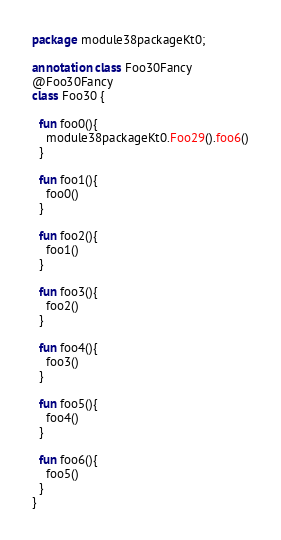<code> <loc_0><loc_0><loc_500><loc_500><_Kotlin_>package module38packageKt0;

annotation class Foo30Fancy
@Foo30Fancy
class Foo30 {

  fun foo0(){
    module38packageKt0.Foo29().foo6()
  }

  fun foo1(){
    foo0()
  }

  fun foo2(){
    foo1()
  }

  fun foo3(){
    foo2()
  }

  fun foo4(){
    foo3()
  }

  fun foo5(){
    foo4()
  }

  fun foo6(){
    foo5()
  }
}</code> 